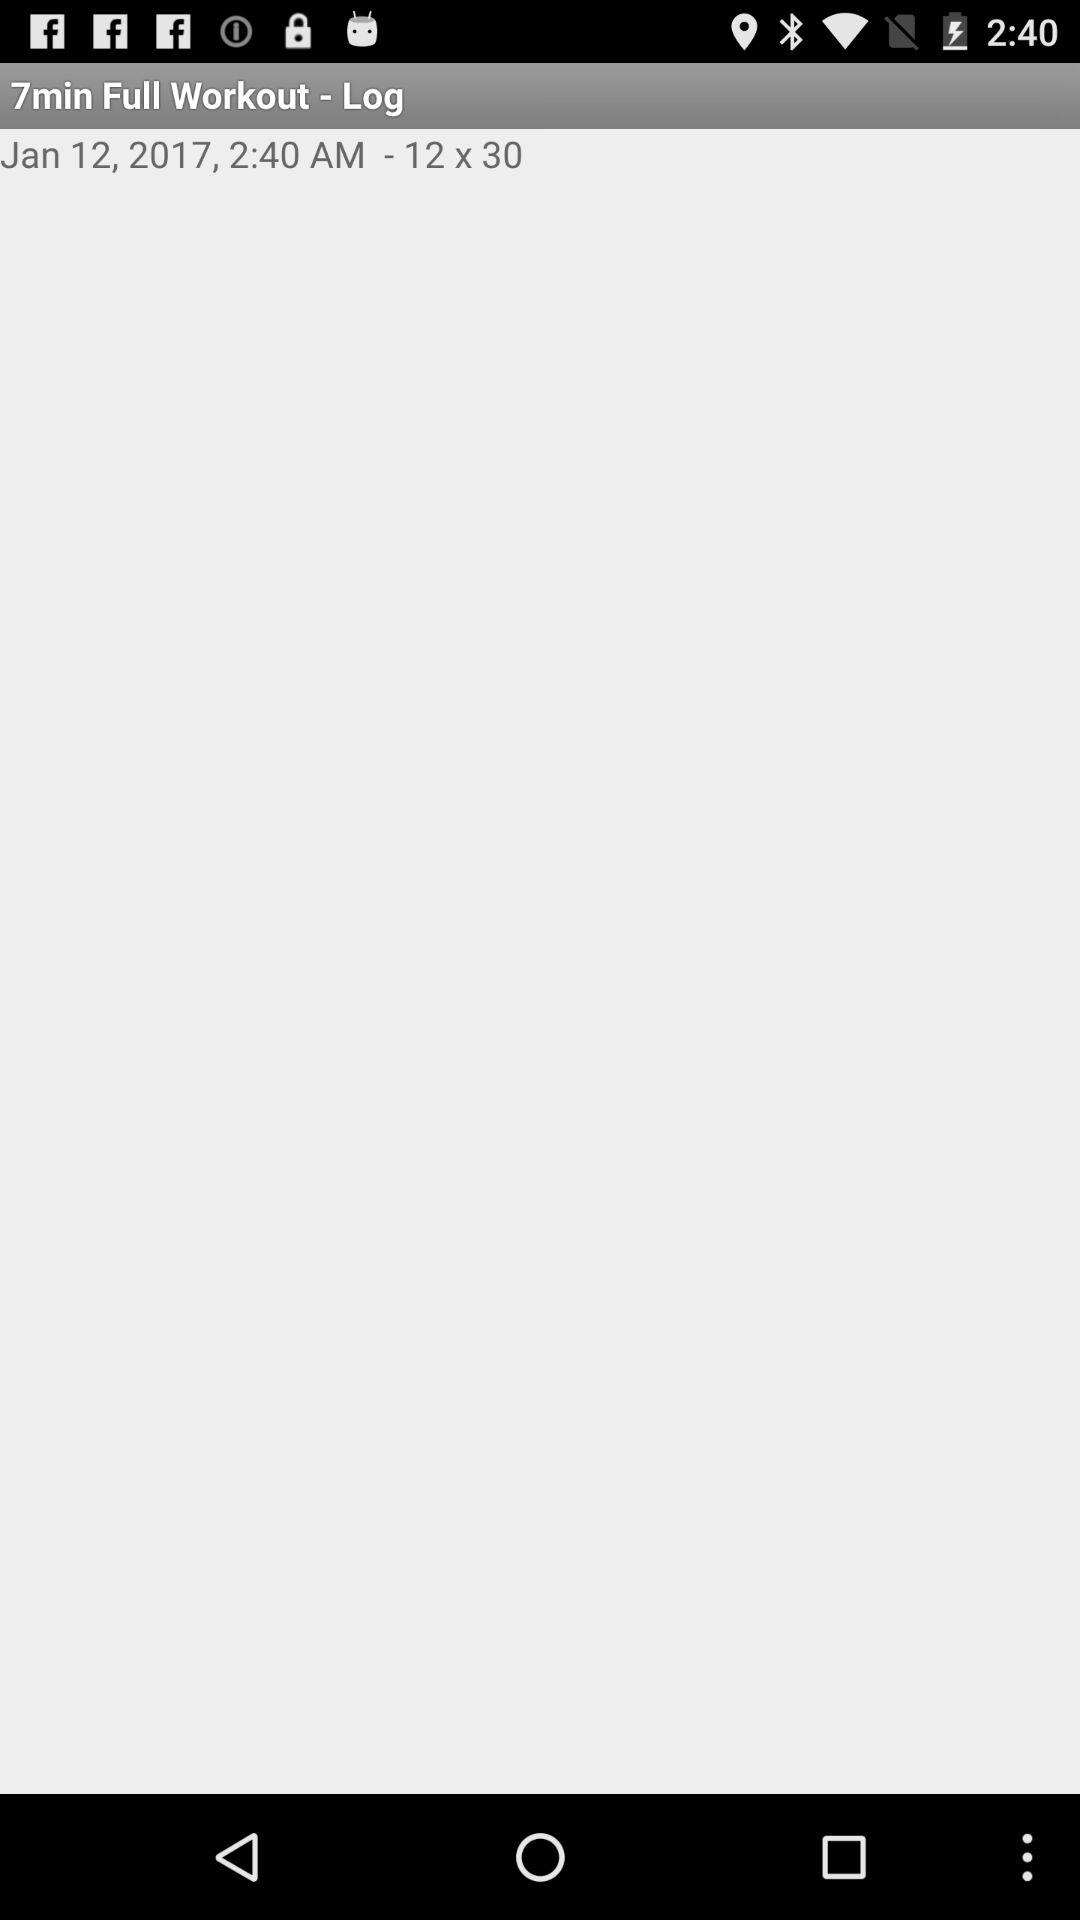What is the date? The date is January 12, 2017. 